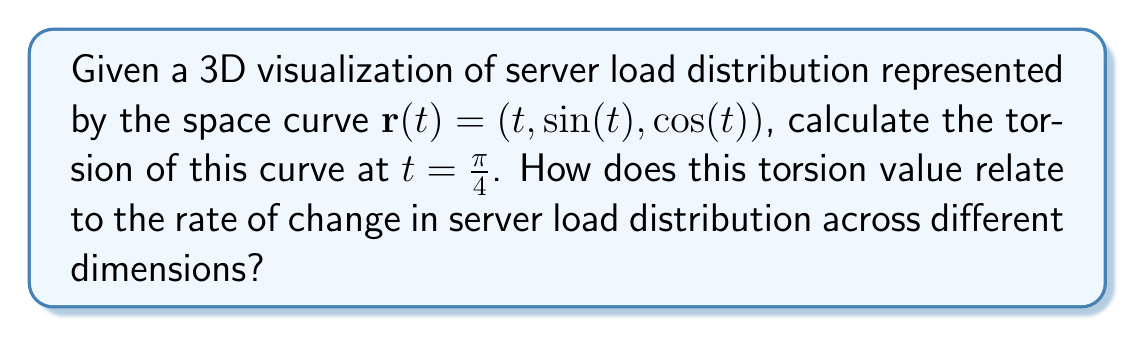Show me your answer to this math problem. To calculate the torsion of the given space curve, we'll follow these steps:

1. Calculate $\mathbf{r}'(t)$, $\mathbf{r}''(t)$, and $\mathbf{r}'''(t)$:
   $$\mathbf{r}'(t) = (1, \cos(t), -\sin(t))$$
   $$\mathbf{r}''(t) = (0, -\sin(t), -\cos(t))$$
   $$\mathbf{r}'''(t) = (0, -\cos(t), \sin(t))$$

2. Calculate the cross product $\mathbf{r}'(t) \times \mathbf{r}''(t)$:
   $$\mathbf{r}'(t) \times \mathbf{r}''(t) = \begin{vmatrix}
   \mathbf{i} & \mathbf{j} & \mathbf{k} \\
   1 & \cos(t) & -\sin(t) \\
   0 & -\sin(t) & -\cos(t)
   \end{vmatrix} = (-\cos^2(t) - \sin^2(t), \sin(t), \cos(t))$$

3. Calculate the scalar triple product $(\mathbf{r}'(t) \times \mathbf{r}''(t)) \cdot \mathbf{r}'''(t)$:
   $$(\mathbf{r}'(t) \times \mathbf{r}''(t)) \cdot \mathbf{r}'''(t) = (-1)(-\cos(t)) + \sin(t)(-\cos(t)) + \cos(t)\sin(t) = \cos(t)$$

4. Calculate $|\mathbf{r}'(t) \times \mathbf{r}''(t)|^2$:
   $$|\mathbf{r}'(t) \times \mathbf{r}''(t)|^2 = (-\cos^2(t) - \sin^2(t))^2 + \sin^2(t) + \cos^2(t) = 1 + 1 = 2$$

5. The torsion formula is:
   $$\tau(t) = \frac{(\mathbf{r}'(t) \times \mathbf{r}''(t)) \cdot \mathbf{r}'''(t)}{|\mathbf{r}'(t) \times \mathbf{r}''(t)|^2}$$

6. Substitute $t = \frac{\pi}{4}$ into the torsion formula:
   $$\tau(\frac{\pi}{4}) = \frac{\cos(\frac{\pi}{4})}{2} = \frac{\frac{\sqrt{2}}{2}}{2} = \frac{\sqrt{2}}{4}$$

The torsion value of $\frac{\sqrt{2}}{4}$ at $t = \frac{\pi}{4}$ indicates how rapidly the osculating plane is rotating around the tangent vector. In the context of server load distribution, this represents the rate at which the load distribution is changing across different dimensions (CPU, memory, network) at that specific point. A non-zero torsion suggests that the load distribution is not planar and is rotating in 3D space, which could indicate complex interactions between different server resources.
Answer: $\frac{\sqrt{2}}{4}$ 